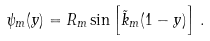Convert formula to latex. <formula><loc_0><loc_0><loc_500><loc_500>\psi _ { m } ( y ) = R _ { m } \sin \left [ \tilde { k } _ { m } ( 1 - y ) \right ] \, .</formula> 